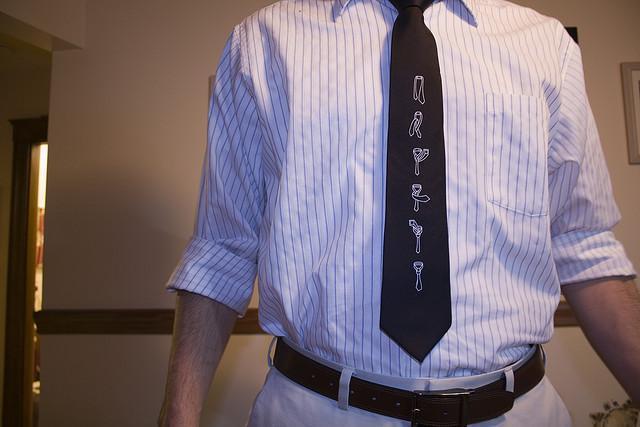The pictograms on the tie show how to do what?
Answer the question by selecting the correct answer among the 4 following choices and explain your choice with a short sentence. The answer should be formatted with the following format: `Answer: choice
Rationale: rationale.`
Options: Make it, iron it, tie it, wash it. Answer: tie it.
Rationale: The pictures are telling to tie. 